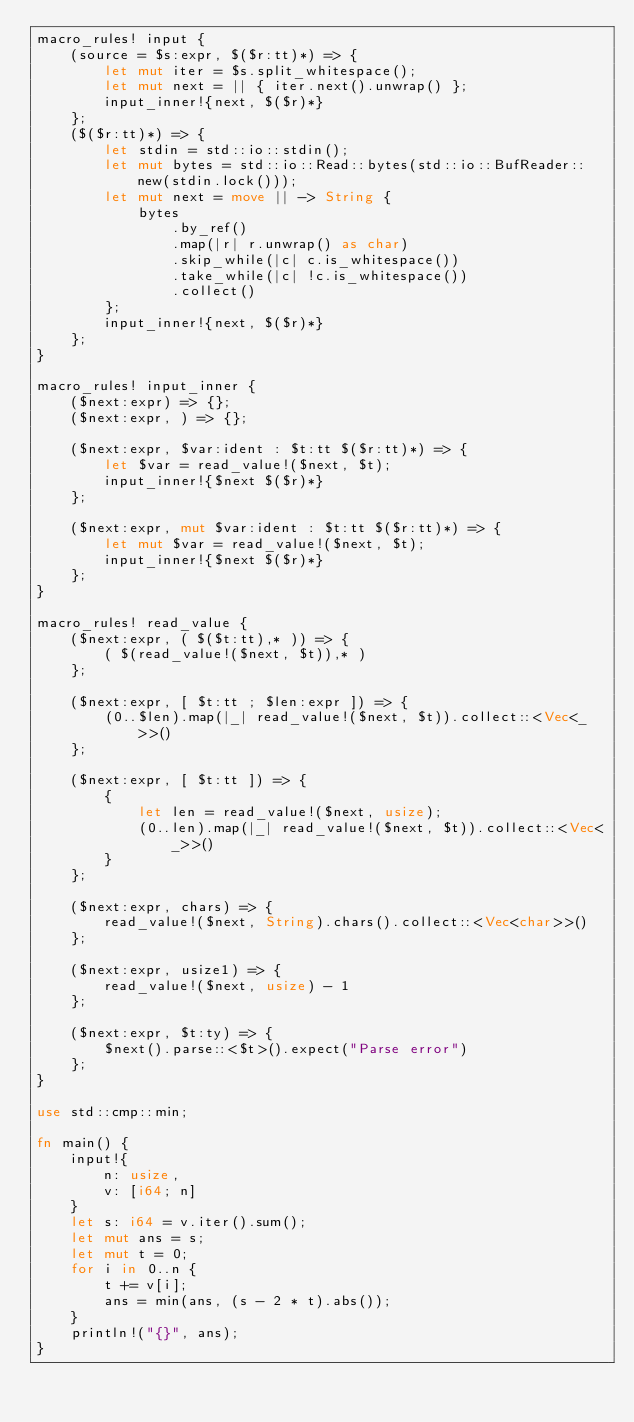Convert code to text. <code><loc_0><loc_0><loc_500><loc_500><_Rust_>macro_rules! input {
    (source = $s:expr, $($r:tt)*) => {
        let mut iter = $s.split_whitespace();
        let mut next = || { iter.next().unwrap() };
        input_inner!{next, $($r)*}
    };
    ($($r:tt)*) => {
        let stdin = std::io::stdin();
        let mut bytes = std::io::Read::bytes(std::io::BufReader::new(stdin.lock()));
        let mut next = move || -> String {
            bytes
                .by_ref()
                .map(|r| r.unwrap() as char)
                .skip_while(|c| c.is_whitespace())
                .take_while(|c| !c.is_whitespace())
                .collect()
        };
        input_inner!{next, $($r)*}
    };
}

macro_rules! input_inner {
    ($next:expr) => {};
    ($next:expr, ) => {};

    ($next:expr, $var:ident : $t:tt $($r:tt)*) => {
        let $var = read_value!($next, $t);
        input_inner!{$next $($r)*}
    };

    ($next:expr, mut $var:ident : $t:tt $($r:tt)*) => {
        let mut $var = read_value!($next, $t);
        input_inner!{$next $($r)*}
    };
}

macro_rules! read_value {
    ($next:expr, ( $($t:tt),* )) => {
        ( $(read_value!($next, $t)),* )
    };

    ($next:expr, [ $t:tt ; $len:expr ]) => {
        (0..$len).map(|_| read_value!($next, $t)).collect::<Vec<_>>()
    };

    ($next:expr, [ $t:tt ]) => {
        {
            let len = read_value!($next, usize);
            (0..len).map(|_| read_value!($next, $t)).collect::<Vec<_>>()
        }
    };

    ($next:expr, chars) => {
        read_value!($next, String).chars().collect::<Vec<char>>()
    };

    ($next:expr, usize1) => {
        read_value!($next, usize) - 1
    };

    ($next:expr, $t:ty) => {
        $next().parse::<$t>().expect("Parse error")
    };
}

use std::cmp::min;

fn main() {
    input!{
        n: usize,
        v: [i64; n]
    }
    let s: i64 = v.iter().sum();
    let mut ans = s;
    let mut t = 0;
    for i in 0..n {
        t += v[i];
        ans = min(ans, (s - 2 * t).abs());
    }
    println!("{}", ans);
}
</code> 